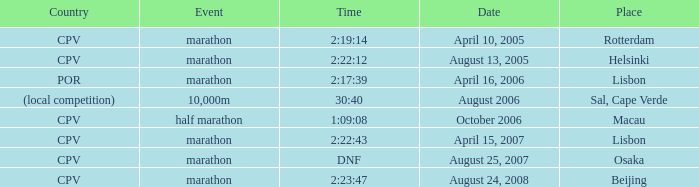I'm looking to parse the entire table for insights. Could you assist me with that? {'header': ['Country', 'Event', 'Time', 'Date', 'Place'], 'rows': [['CPV', 'marathon', '2:19:14', 'April 10, 2005', 'Rotterdam'], ['CPV', 'marathon', '2:22:12', 'August 13, 2005', 'Helsinki'], ['POR', 'marathon', '2:17:39', 'April 16, 2006', 'Lisbon'], ['(local competition)', '10,000m', '30:40', 'August 2006', 'Sal, Cape Verde'], ['CPV', 'half marathon', '1:09:08', 'October 2006', 'Macau'], ['CPV', 'marathon', '2:22:43', 'April 15, 2007', 'Lisbon'], ['CPV', 'marathon', 'DNF', 'August 25, 2007', 'Osaka'], ['CPV', 'marathon', '2:23:47', 'August 24, 2008', 'Beijing']]} What is the nation of the half marathon event? CPV. 